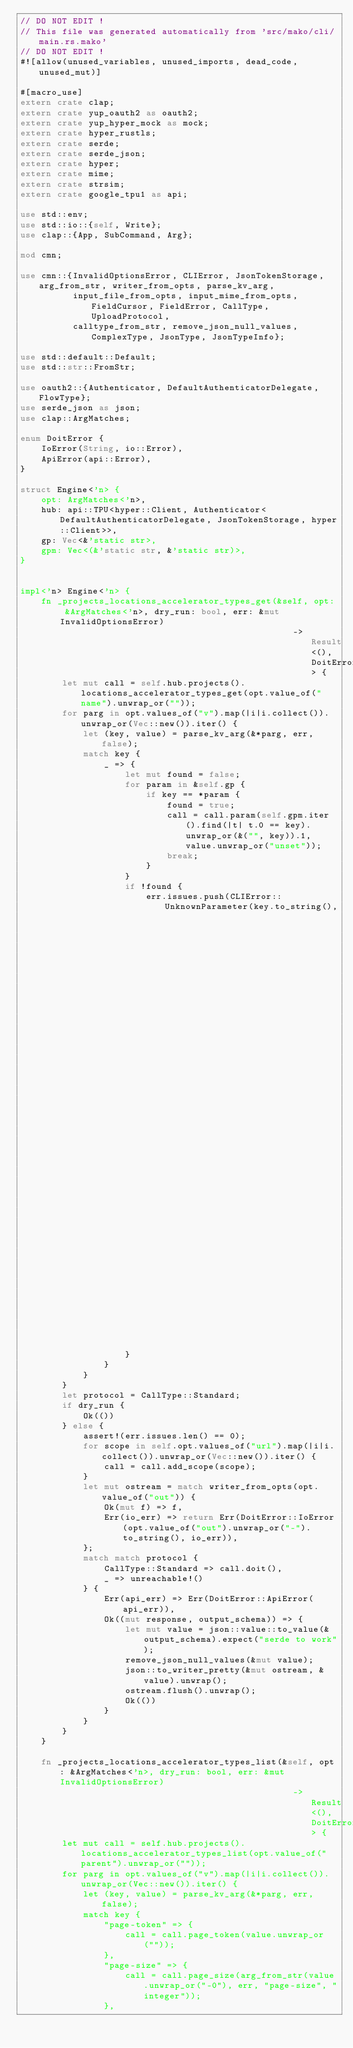<code> <loc_0><loc_0><loc_500><loc_500><_Rust_>// DO NOT EDIT !
// This file was generated automatically from 'src/mako/cli/main.rs.mako'
// DO NOT EDIT !
#![allow(unused_variables, unused_imports, dead_code, unused_mut)]

#[macro_use]
extern crate clap;
extern crate yup_oauth2 as oauth2;
extern crate yup_hyper_mock as mock;
extern crate hyper_rustls;
extern crate serde;
extern crate serde_json;
extern crate hyper;
extern crate mime;
extern crate strsim;
extern crate google_tpu1 as api;

use std::env;
use std::io::{self, Write};
use clap::{App, SubCommand, Arg};

mod cmn;

use cmn::{InvalidOptionsError, CLIError, JsonTokenStorage, arg_from_str, writer_from_opts, parse_kv_arg,
          input_file_from_opts, input_mime_from_opts, FieldCursor, FieldError, CallType, UploadProtocol,
          calltype_from_str, remove_json_null_values, ComplexType, JsonType, JsonTypeInfo};

use std::default::Default;
use std::str::FromStr;

use oauth2::{Authenticator, DefaultAuthenticatorDelegate, FlowType};
use serde_json as json;
use clap::ArgMatches;

enum DoitError {
    IoError(String, io::Error),
    ApiError(api::Error),
}

struct Engine<'n> {
    opt: ArgMatches<'n>,
    hub: api::TPU<hyper::Client, Authenticator<DefaultAuthenticatorDelegate, JsonTokenStorage, hyper::Client>>,
    gp: Vec<&'static str>,
    gpm: Vec<(&'static str, &'static str)>,
}


impl<'n> Engine<'n> {
    fn _projects_locations_accelerator_types_get(&self, opt: &ArgMatches<'n>, dry_run: bool, err: &mut InvalidOptionsError)
                                                    -> Result<(), DoitError> {
        let mut call = self.hub.projects().locations_accelerator_types_get(opt.value_of("name").unwrap_or(""));
        for parg in opt.values_of("v").map(|i|i.collect()).unwrap_or(Vec::new()).iter() {
            let (key, value) = parse_kv_arg(&*parg, err, false);
            match key {
                _ => {
                    let mut found = false;
                    for param in &self.gp {
                        if key == *param {
                            found = true;
                            call = call.param(self.gpm.iter().find(|t| t.0 == key).unwrap_or(&("", key)).1, value.unwrap_or("unset"));
                            break;
                        }
                    }
                    if !found {
                        err.issues.push(CLIError::UnknownParameter(key.to_string(),
                                                                  {let mut v = Vec::new();
                                                                           v.extend(self.gp.iter().map(|v|*v));
                                                                           v } ));
                    }
                }
            }
        }
        let protocol = CallType::Standard;
        if dry_run {
            Ok(())
        } else {
            assert!(err.issues.len() == 0);
            for scope in self.opt.values_of("url").map(|i|i.collect()).unwrap_or(Vec::new()).iter() {
                call = call.add_scope(scope);
            }
            let mut ostream = match writer_from_opts(opt.value_of("out")) {
                Ok(mut f) => f,
                Err(io_err) => return Err(DoitError::IoError(opt.value_of("out").unwrap_or("-").to_string(), io_err)),
            };
            match match protocol {
                CallType::Standard => call.doit(),
                _ => unreachable!()
            } {
                Err(api_err) => Err(DoitError::ApiError(api_err)),
                Ok((mut response, output_schema)) => {
                    let mut value = json::value::to_value(&output_schema).expect("serde to work");
                    remove_json_null_values(&mut value);
                    json::to_writer_pretty(&mut ostream, &value).unwrap();
                    ostream.flush().unwrap();
                    Ok(())
                }
            }
        }
    }

    fn _projects_locations_accelerator_types_list(&self, opt: &ArgMatches<'n>, dry_run: bool, err: &mut InvalidOptionsError)
                                                    -> Result<(), DoitError> {
        let mut call = self.hub.projects().locations_accelerator_types_list(opt.value_of("parent").unwrap_or(""));
        for parg in opt.values_of("v").map(|i|i.collect()).unwrap_or(Vec::new()).iter() {
            let (key, value) = parse_kv_arg(&*parg, err, false);
            match key {
                "page-token" => {
                    call = call.page_token(value.unwrap_or(""));
                },
                "page-size" => {
                    call = call.page_size(arg_from_str(value.unwrap_or("-0"), err, "page-size", "integer"));
                },</code> 